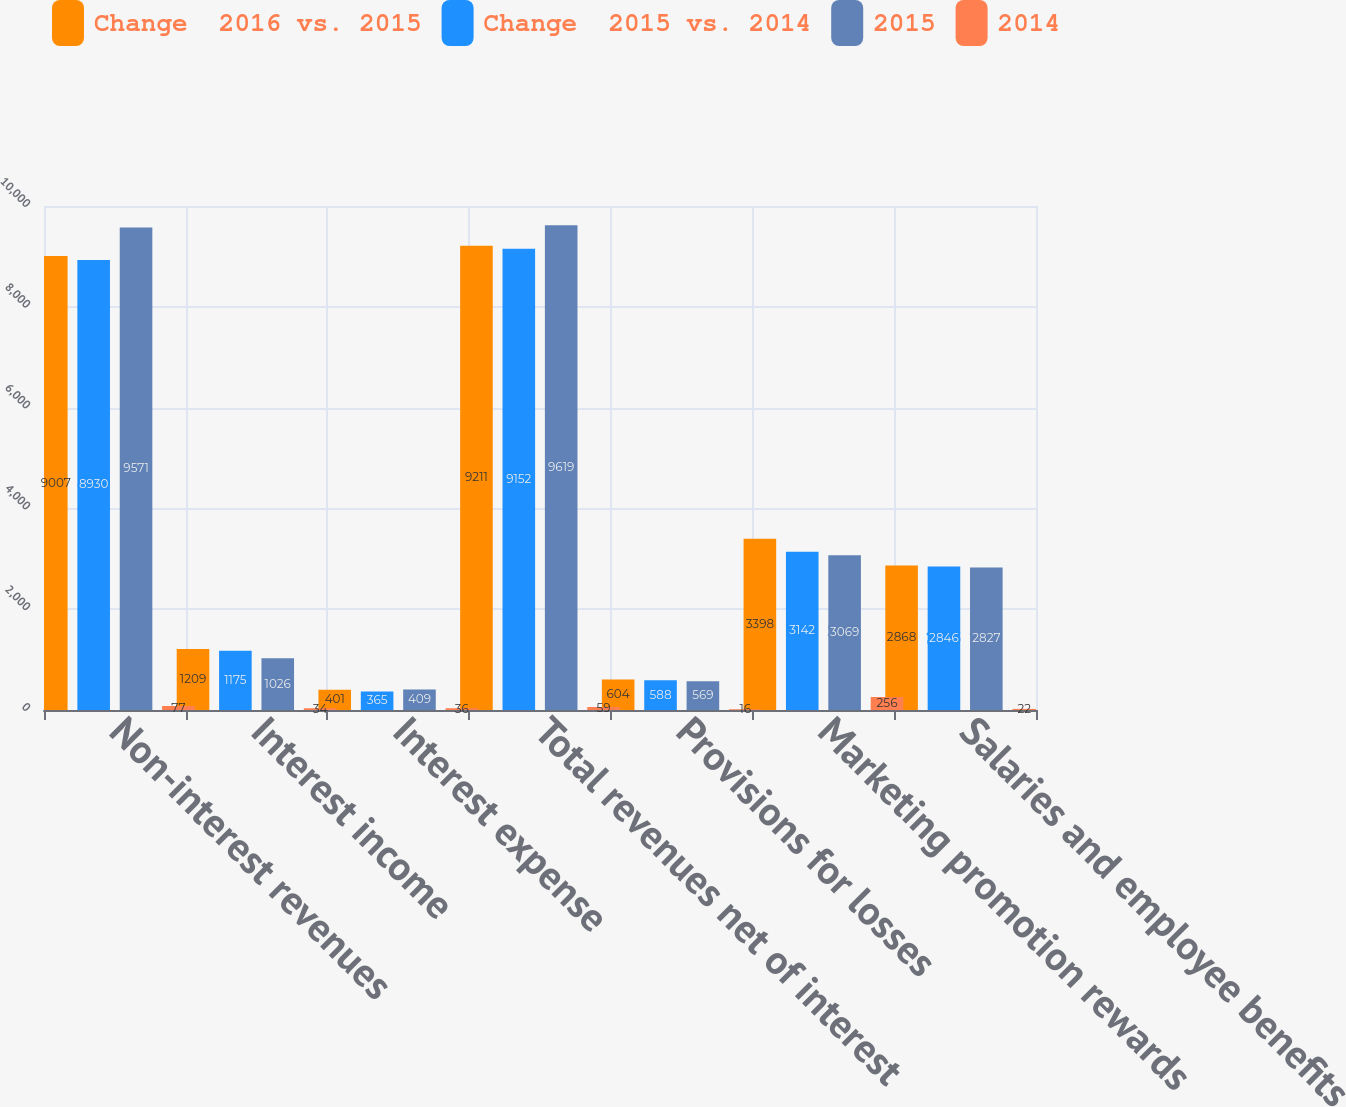Convert chart to OTSL. <chart><loc_0><loc_0><loc_500><loc_500><stacked_bar_chart><ecel><fcel>Non-interest revenues<fcel>Interest income<fcel>Interest expense<fcel>Total revenues net of interest<fcel>Provisions for losses<fcel>Marketing promotion rewards<fcel>Salaries and employee benefits<nl><fcel>Change  2016 vs. 2015<fcel>9007<fcel>1209<fcel>401<fcel>9211<fcel>604<fcel>3398<fcel>2868<nl><fcel>Change  2015 vs. 2014<fcel>8930<fcel>1175<fcel>365<fcel>9152<fcel>588<fcel>3142<fcel>2846<nl><fcel>2015<fcel>9571<fcel>1026<fcel>409<fcel>9619<fcel>569<fcel>3069<fcel>2827<nl><fcel>2014<fcel>77<fcel>34<fcel>36<fcel>59<fcel>16<fcel>256<fcel>22<nl></chart> 